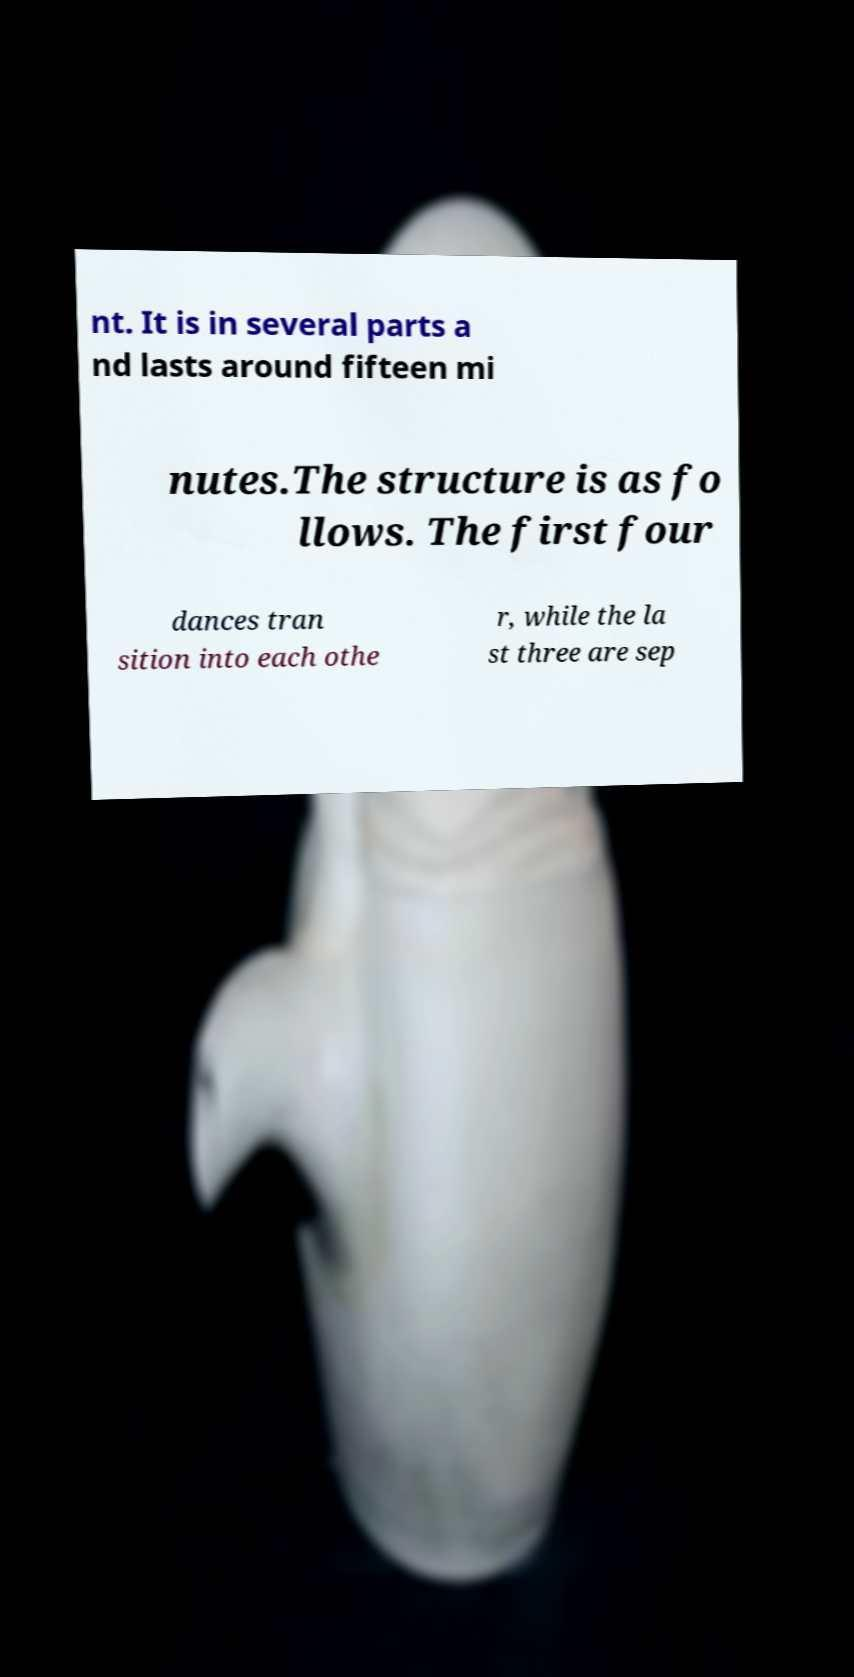Can you read and provide the text displayed in the image?This photo seems to have some interesting text. Can you extract and type it out for me? nt. It is in several parts a nd lasts around fifteen mi nutes.The structure is as fo llows. The first four dances tran sition into each othe r, while the la st three are sep 